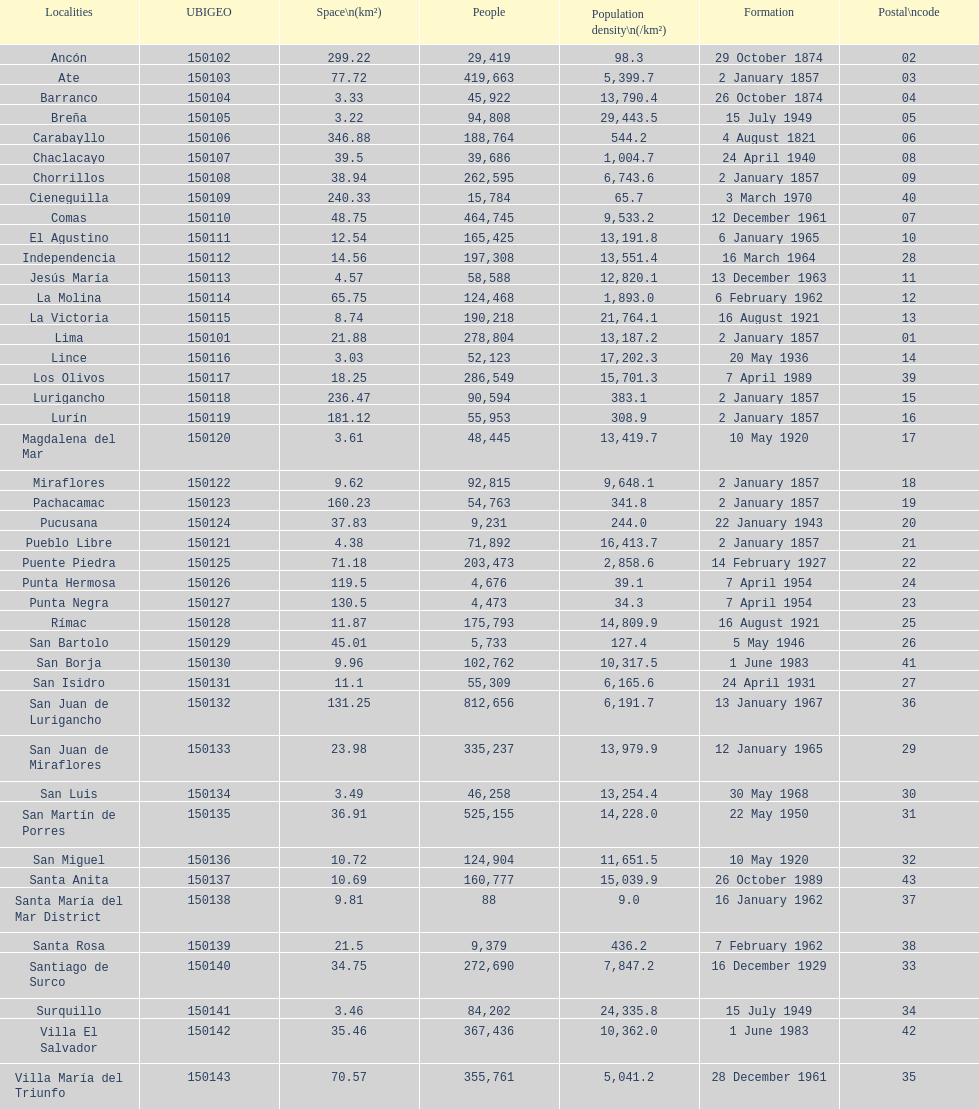What district has the least amount of population? Santa María del Mar District. 